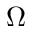Convert formula to latex. <formula><loc_0><loc_0><loc_500><loc_500>\Omega</formula> 